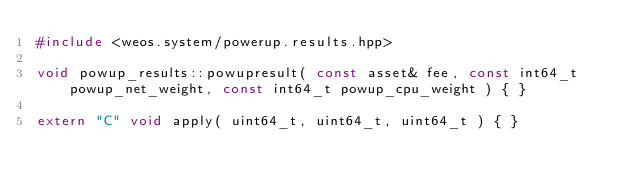<code> <loc_0><loc_0><loc_500><loc_500><_C++_>#include <weos.system/powerup.results.hpp>

void powup_results::powupresult( const asset& fee, const int64_t powup_net_weight, const int64_t powup_cpu_weight ) { }

extern "C" void apply( uint64_t, uint64_t, uint64_t ) { }
</code> 